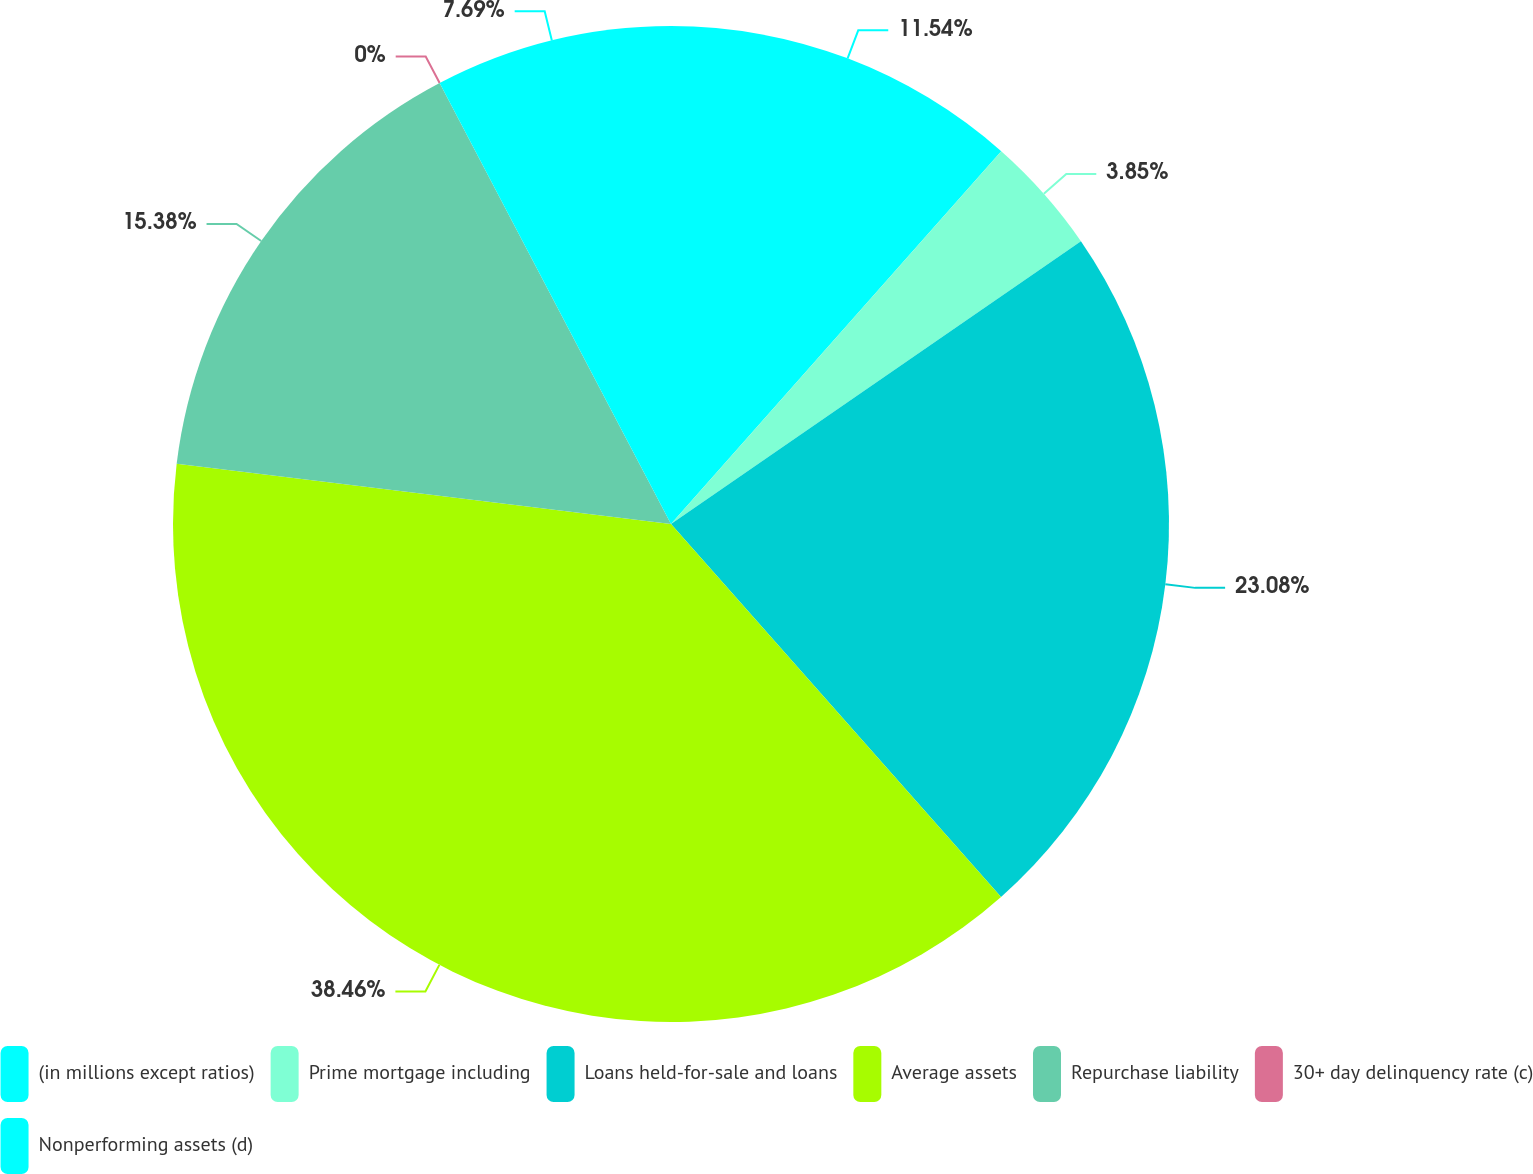Convert chart. <chart><loc_0><loc_0><loc_500><loc_500><pie_chart><fcel>(in millions except ratios)<fcel>Prime mortgage including<fcel>Loans held-for-sale and loans<fcel>Average assets<fcel>Repurchase liability<fcel>30+ day delinquency rate (c)<fcel>Nonperforming assets (d)<nl><fcel>11.54%<fcel>3.85%<fcel>23.08%<fcel>38.46%<fcel>15.38%<fcel>0.0%<fcel>7.69%<nl></chart> 